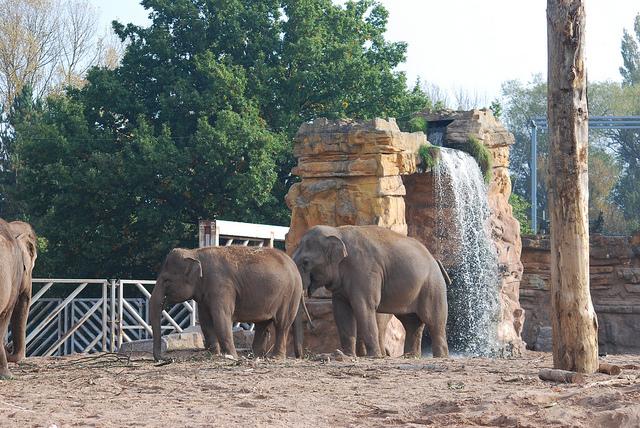How many elephants are seen in the image?
Answer briefly. 3. Is the waterfall natural?
Answer briefly. No. Which tree has many dark green leaves?
Keep it brief. In back. 